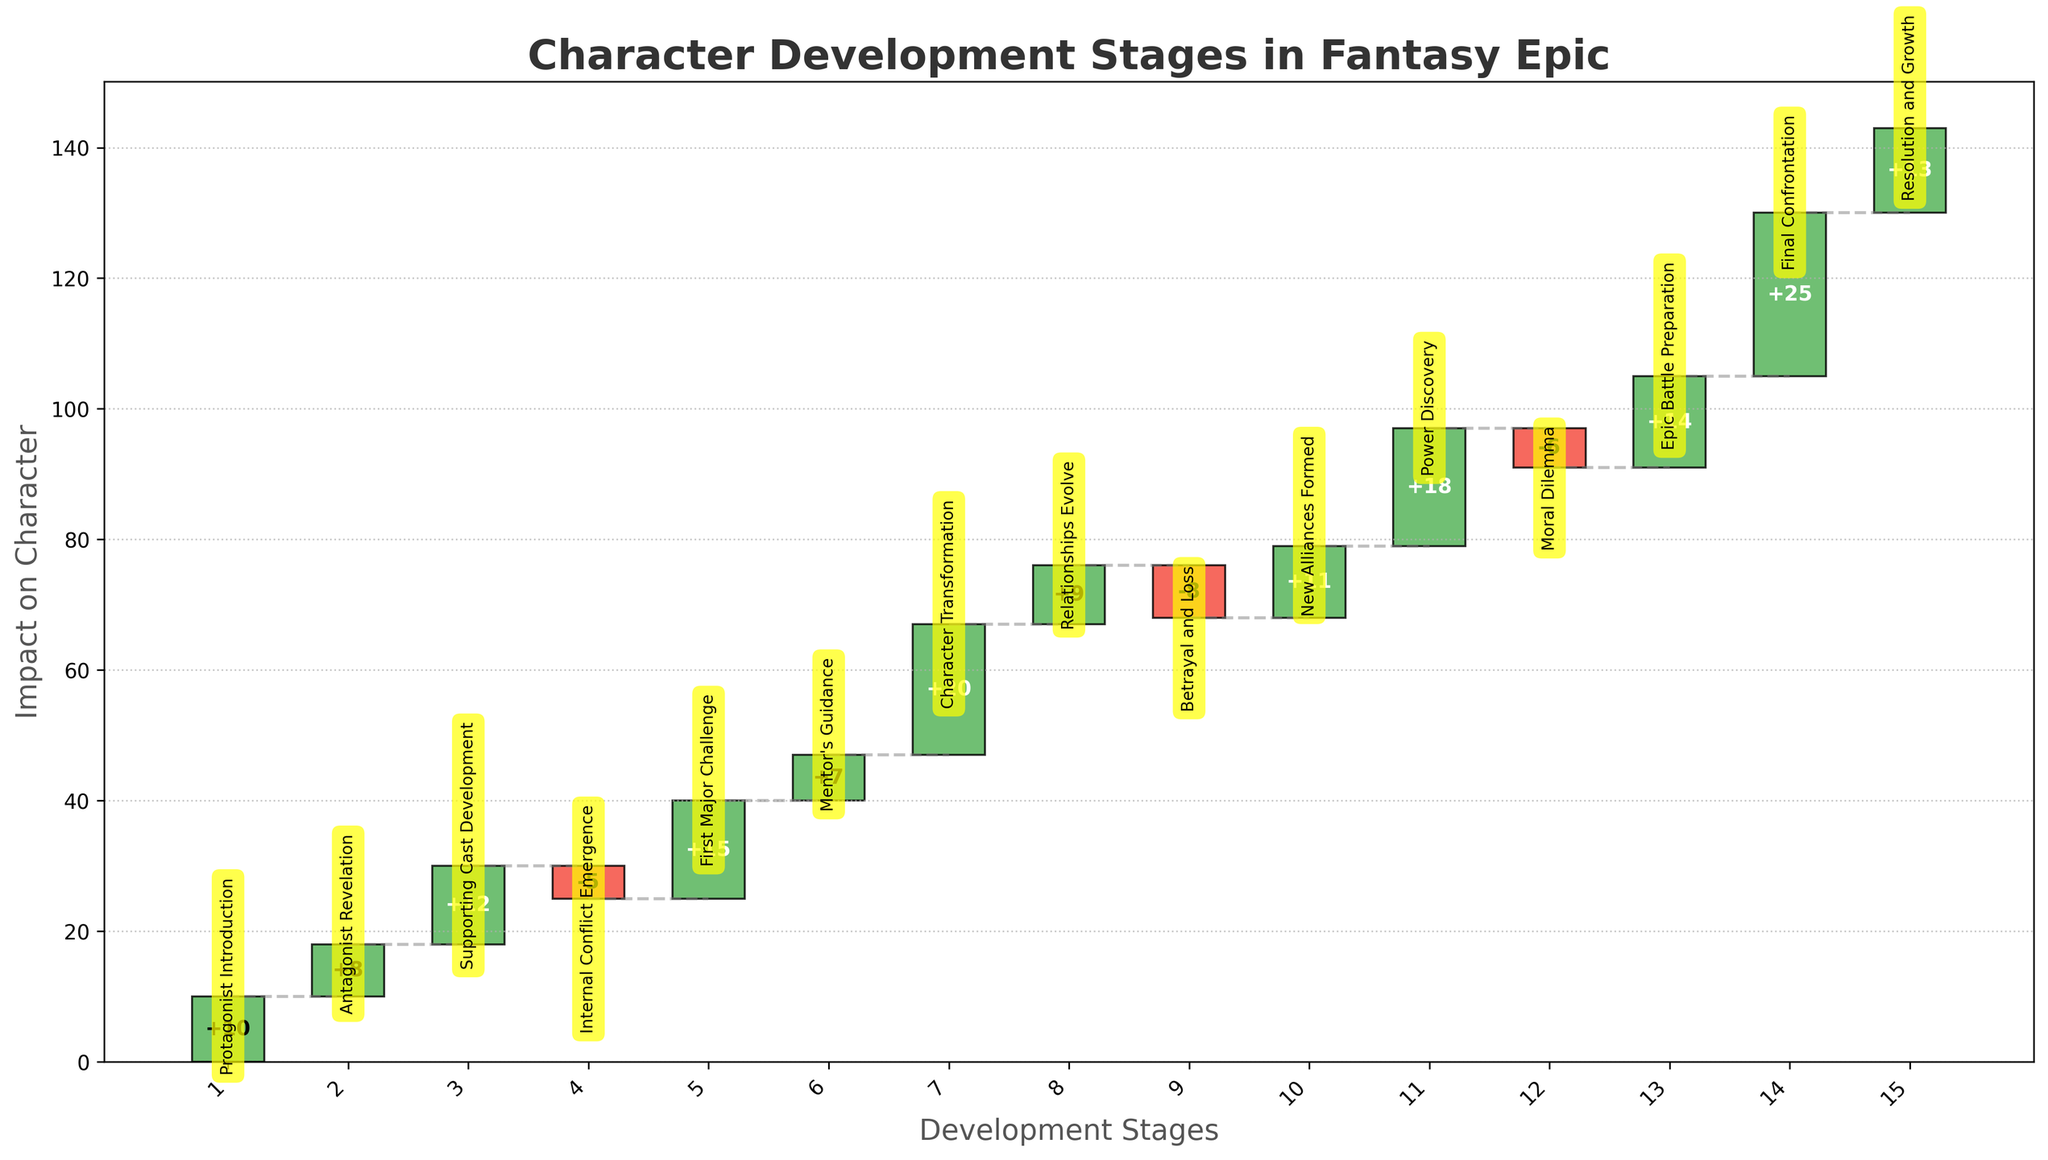What's the title of the chart? The title of the chart is displayed at the top in a large, bold font.
Answer: Character Development Stages in Fantasy Epic What is the stage with the highest positive value? The highest positive value is 25, which is identified by looking at the bar that has the tallest height in the positive direction. This corresponds to "Final Confrontation" at stage 14.
Answer: Final Confrontation How many stages have a negative value? The negative values are represented by bars extending downward. By counting these, we find that there are three stages with negative values: Internal Conflict Emergence, Betrayal and Loss, and Moral Dilemma.
Answer: Three What is the cumulative value at the end of the chart? The cumulative value at the end of the chart can be found by summing up all the values or observing the ending point of the final bar, which corresponds here to 133.
Answer: 133 Between which stages does the first significant change in character impact occur? The first significant positive change is identified by the sharp upward movement in the cumulative value. This occurs between Protagonist Introduction and Antagonist Revelation, changing from 10 to 18 (difference of +8).
Answer: Stages 1 and 2 What's the cumulative impact on the character by the time the Mentor's Guidance stage is reached? To calculate this, sum the values up to the Mentor's Guidance stage. Starting cumulative value at the first stage Protagonist Introduction is 10. It then adds values of Antagonist Revelation (+8), Supporting Cast Development (+12), Internal Conflict Emergence (-5), and First Major Challenge (+15) and finally adds Mentor’s Guidance (+7). The cumulative impact up to Mentor's Guidance is (10 + 8 + 12 - 5 + 15 + 7) = 47.
Answer: 47 Compare the impact of Character Transformation to New Alliances Formed. Which one had a greater positive impact? To identify the greater impact, compare the heights of the bars for Character Transformation (value 20) and New Alliances Formed (value 11). Character Transformation has a greater positive impact.
Answer: Character Transformation Which stage immediately follows Betrayal and Loss, and what value does this stage contribute? After identifying Betrayal and Loss at stage 9 with a value of -8, observe the next bar upwards at stage 10, New Alliances Formed, with a value of 11.
Answer: New Alliances Formed, 11 What impact did the Moral Dilemma stage have on the character's development? The value associated with the Moral Dilemma stage is directly shown as -6, indicating a negative impact.
Answer: -6 What is the total change in value from the Epic Battle Preparation stage to the Resolution and Growth stage? To find the change, calculate the difference between the cumulative values at stages 13 and 15. The values for these are 14 (Epic Battle Preparation) and 13 (Resolution and Growth). Cumulative at Epic Battle Preparation is 104 (sum up all values before it: 10 + 8 + 12 - 5 + 15 + 7 + 20 + 9 -8 + 11 + 18 -6). Then, add 14 (Epic Battle Preparation) -> 118, finally add 25 for Final Confrontation (143), ending with adding 13 for Resolution and Growth making the total 156. Therefore, change from 118 to 156 -> (156 - 118 = 38).
Answer: 38 